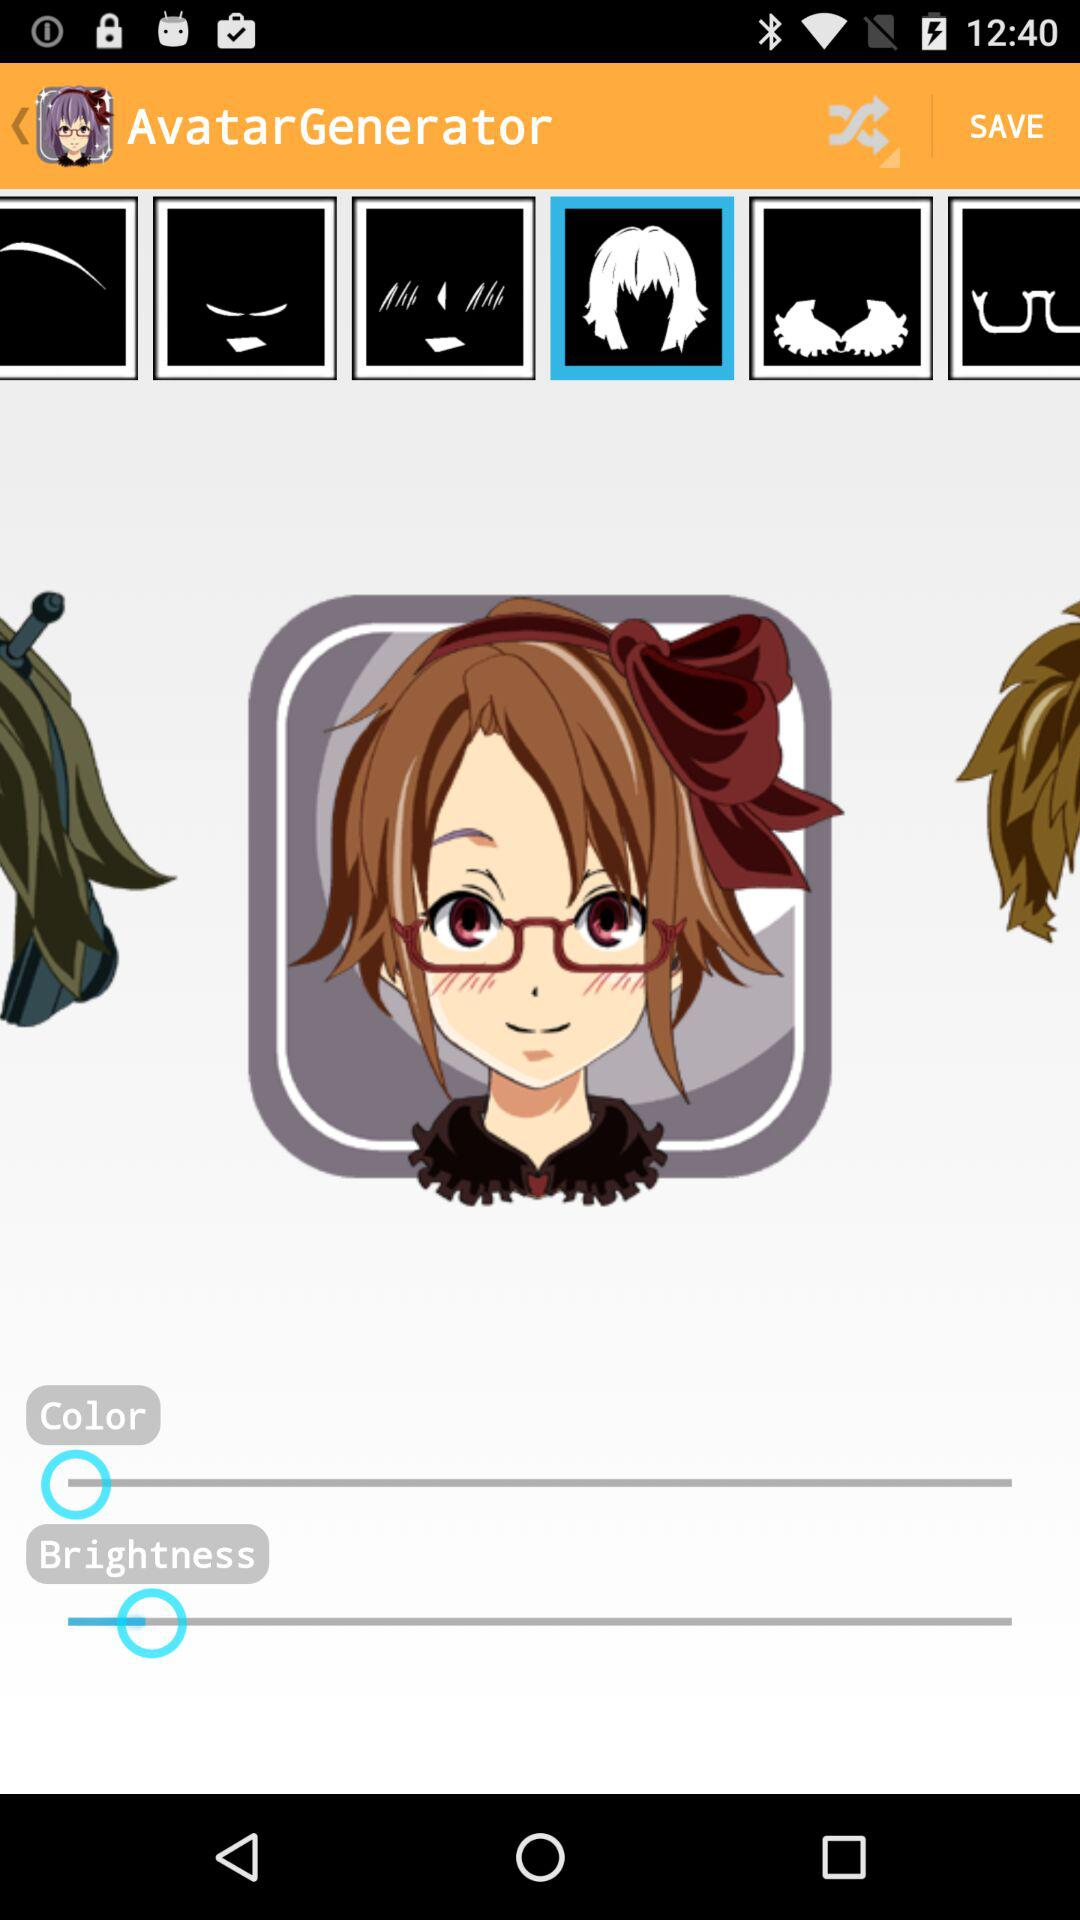What is the application name? The application name is "Avatar Maker Android". 